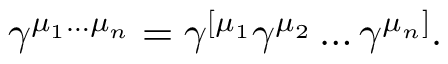Convert formula to latex. <formula><loc_0><loc_0><loc_500><loc_500>\gamma ^ { \mu _ { 1 } \dots \mu _ { n } } = \gamma ^ { [ \mu _ { 1 } } \gamma ^ { \mu _ { 2 } } \dots \gamma ^ { \mu _ { n } ] } .</formula> 